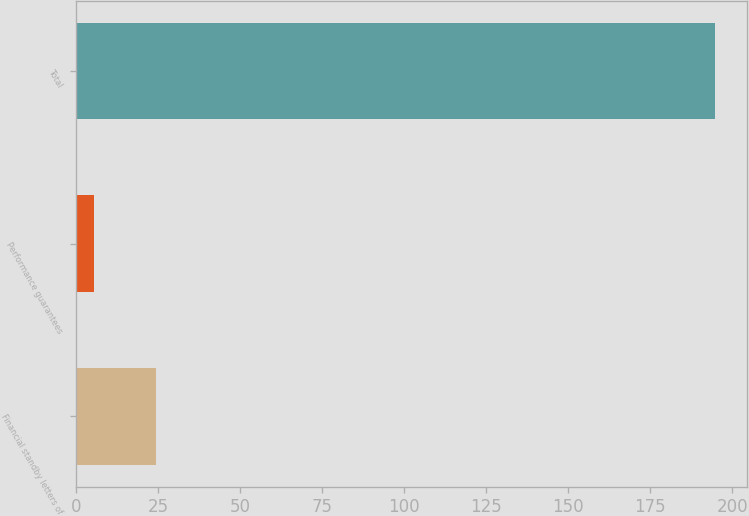<chart> <loc_0><loc_0><loc_500><loc_500><bar_chart><fcel>Financial standby letters of<fcel>Performance guarantees<fcel>Total<nl><fcel>24.52<fcel>5.6<fcel>194.8<nl></chart> 